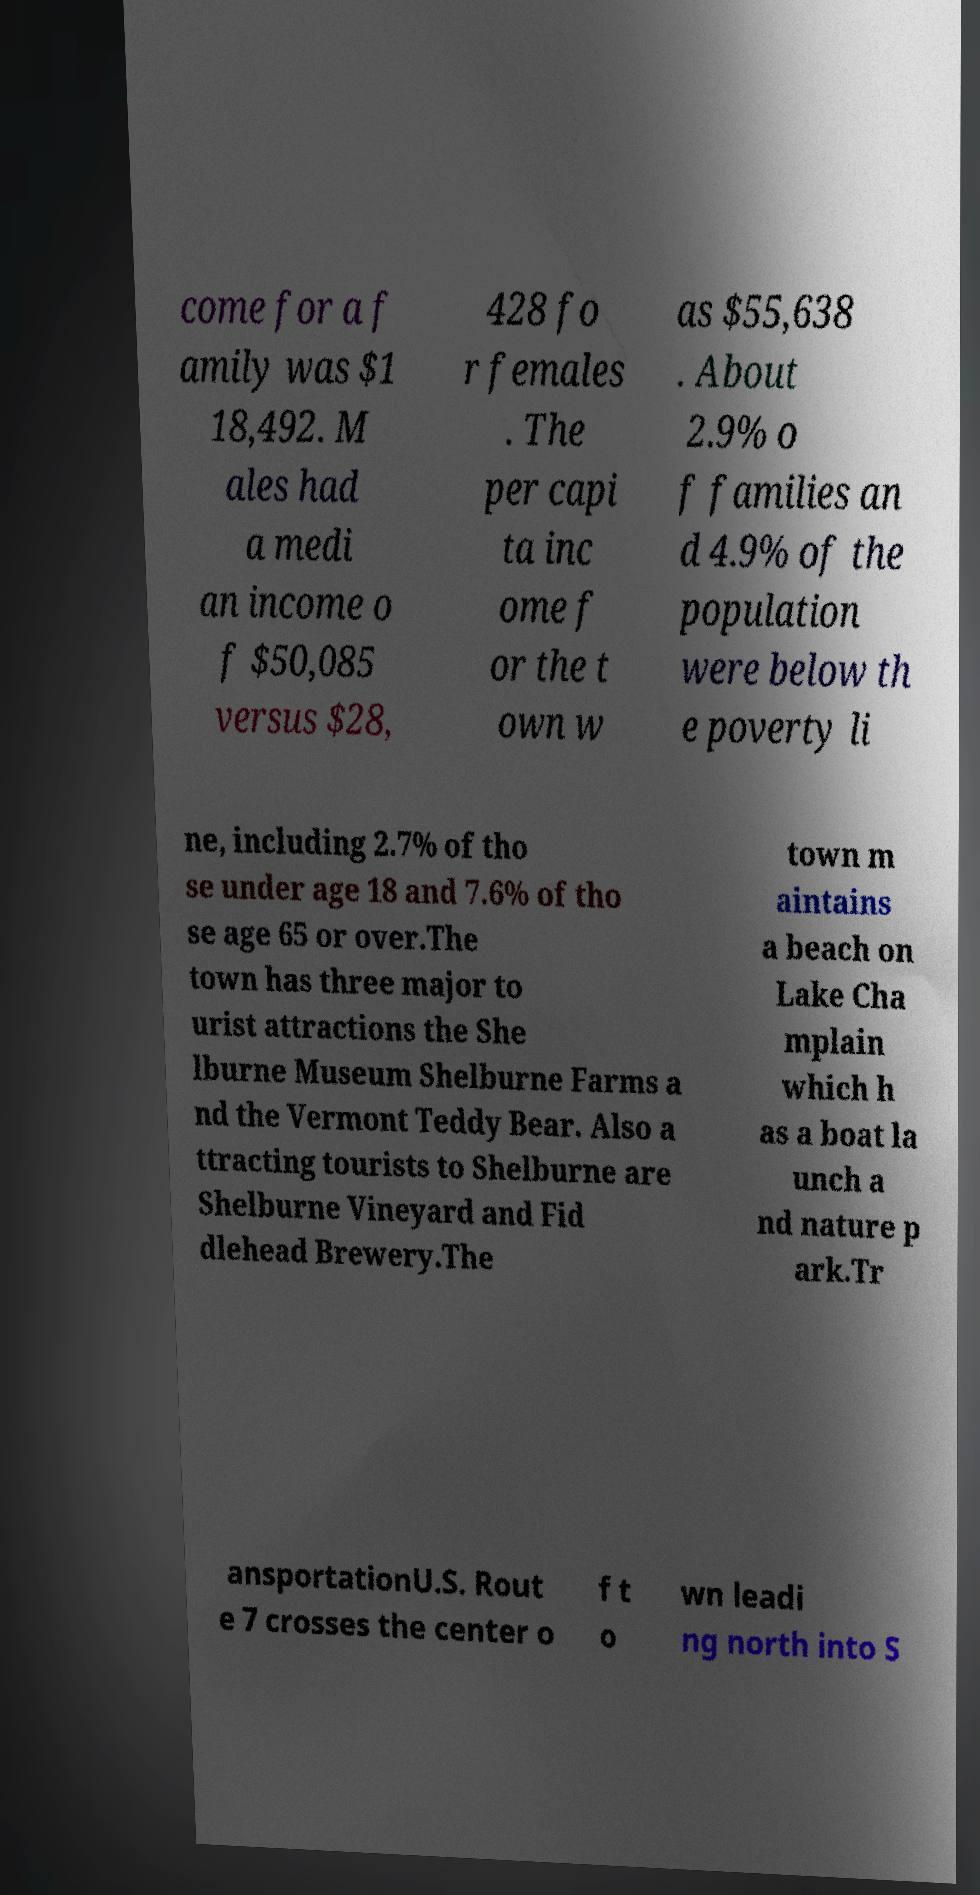Can you read and provide the text displayed in the image?This photo seems to have some interesting text. Can you extract and type it out for me? come for a f amily was $1 18,492. M ales had a medi an income o f $50,085 versus $28, 428 fo r females . The per capi ta inc ome f or the t own w as $55,638 . About 2.9% o f families an d 4.9% of the population were below th e poverty li ne, including 2.7% of tho se under age 18 and 7.6% of tho se age 65 or over.The town has three major to urist attractions the She lburne Museum Shelburne Farms a nd the Vermont Teddy Bear. Also a ttracting tourists to Shelburne are Shelburne Vineyard and Fid dlehead Brewery.The town m aintains a beach on Lake Cha mplain which h as a boat la unch a nd nature p ark.Tr ansportationU.S. Rout e 7 crosses the center o f t o wn leadi ng north into S 